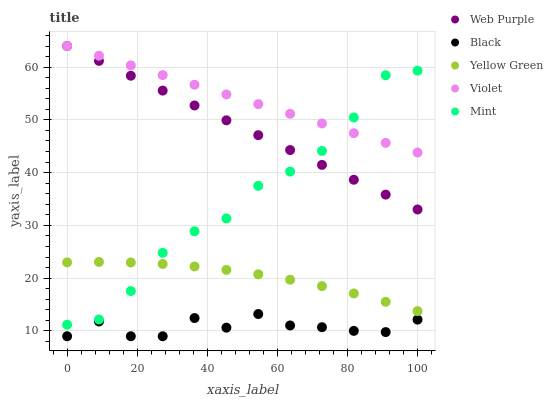Does Black have the minimum area under the curve?
Answer yes or no. Yes. Does Violet have the maximum area under the curve?
Answer yes or no. Yes. Does Web Purple have the minimum area under the curve?
Answer yes or no. No. Does Web Purple have the maximum area under the curve?
Answer yes or no. No. Is Violet the smoothest?
Answer yes or no. Yes. Is Black the roughest?
Answer yes or no. Yes. Is Web Purple the smoothest?
Answer yes or no. No. Is Web Purple the roughest?
Answer yes or no. No. Does Black have the lowest value?
Answer yes or no. Yes. Does Web Purple have the lowest value?
Answer yes or no. No. Does Violet have the highest value?
Answer yes or no. Yes. Does Black have the highest value?
Answer yes or no. No. Is Yellow Green less than Web Purple?
Answer yes or no. Yes. Is Mint greater than Black?
Answer yes or no. Yes. Does Mint intersect Violet?
Answer yes or no. Yes. Is Mint less than Violet?
Answer yes or no. No. Is Mint greater than Violet?
Answer yes or no. No. Does Yellow Green intersect Web Purple?
Answer yes or no. No. 